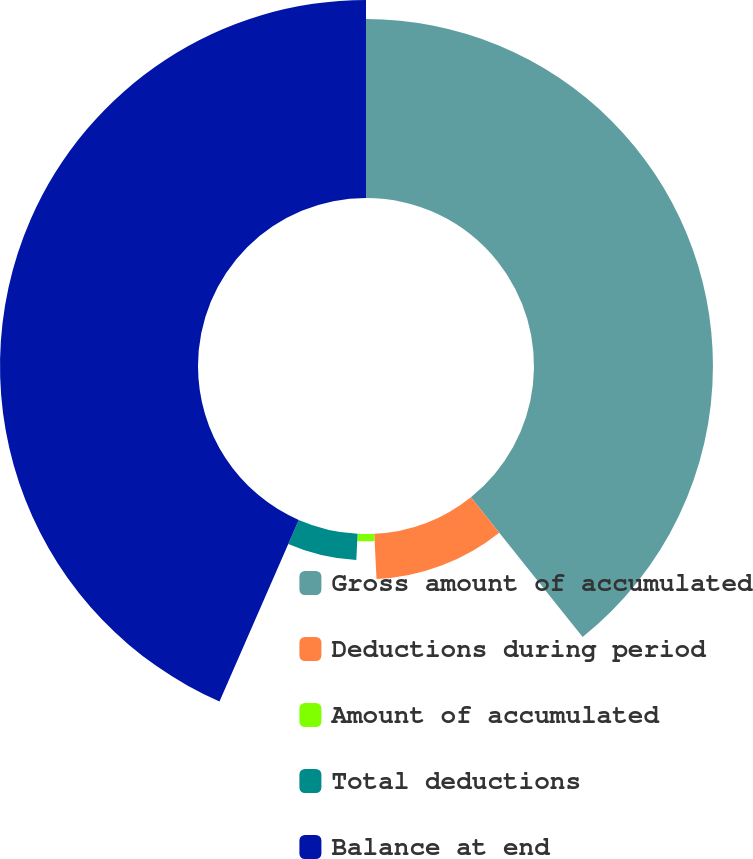Convert chart to OTSL. <chart><loc_0><loc_0><loc_500><loc_500><pie_chart><fcel>Gross amount of accumulated<fcel>Deductions during period<fcel>Amount of accumulated<fcel>Total deductions<fcel>Balance at end<nl><fcel>39.27%<fcel>9.95%<fcel>1.58%<fcel>5.76%<fcel>43.45%<nl></chart> 